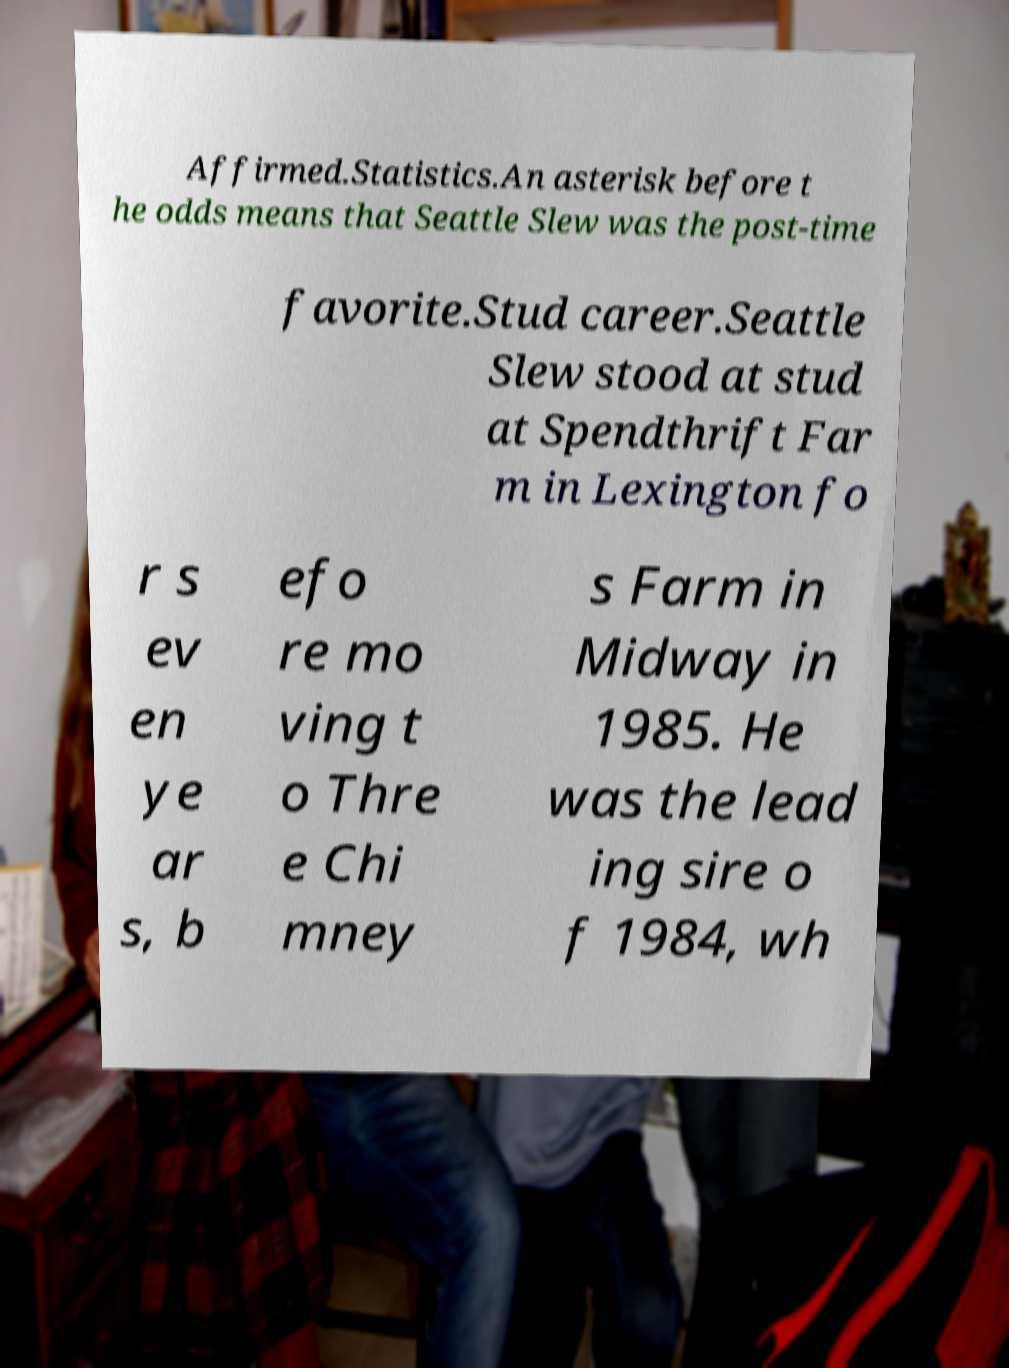Could you extract and type out the text from this image? Affirmed.Statistics.An asterisk before t he odds means that Seattle Slew was the post-time favorite.Stud career.Seattle Slew stood at stud at Spendthrift Far m in Lexington fo r s ev en ye ar s, b efo re mo ving t o Thre e Chi mney s Farm in Midway in 1985. He was the lead ing sire o f 1984, wh 